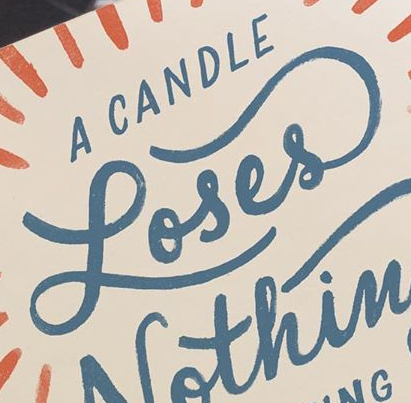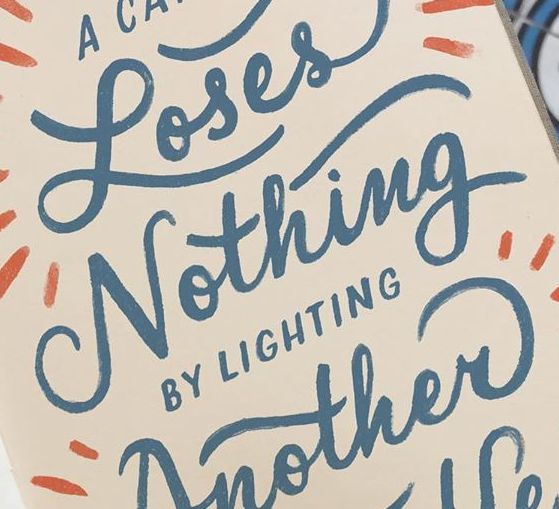Identify the words shown in these images in order, separated by a semicolon. Loses; Nothing 